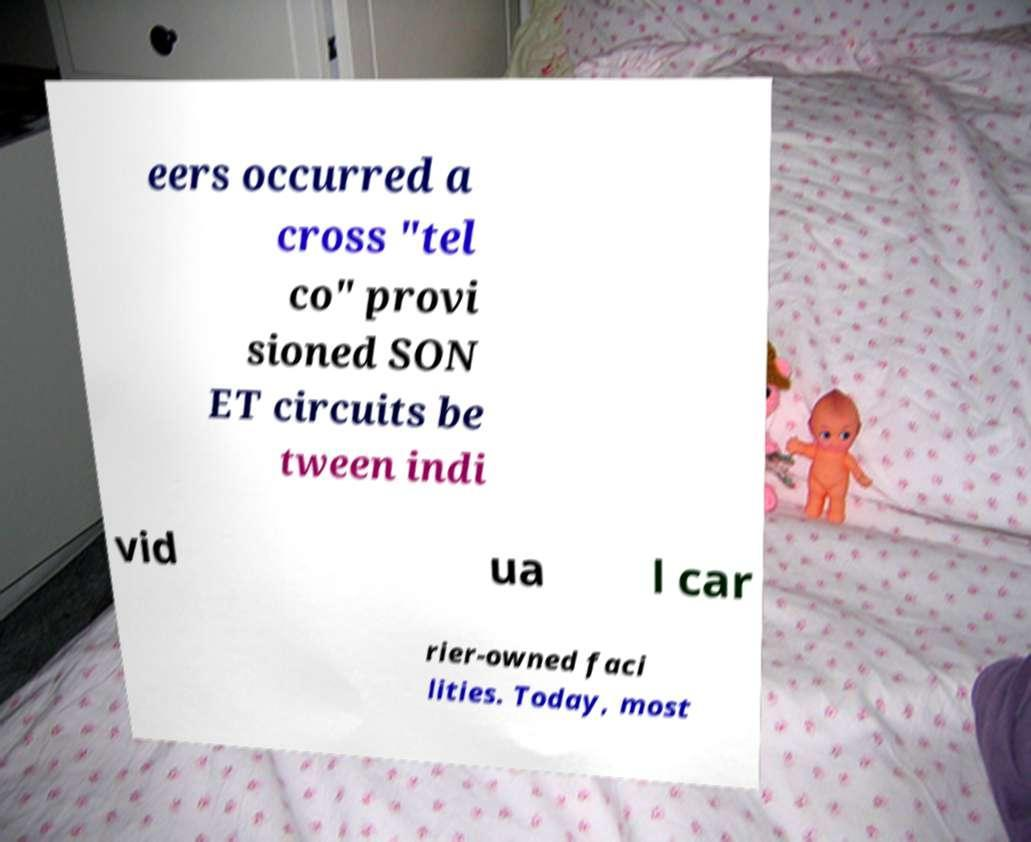Could you assist in decoding the text presented in this image and type it out clearly? eers occurred a cross "tel co" provi sioned SON ET circuits be tween indi vid ua l car rier-owned faci lities. Today, most 